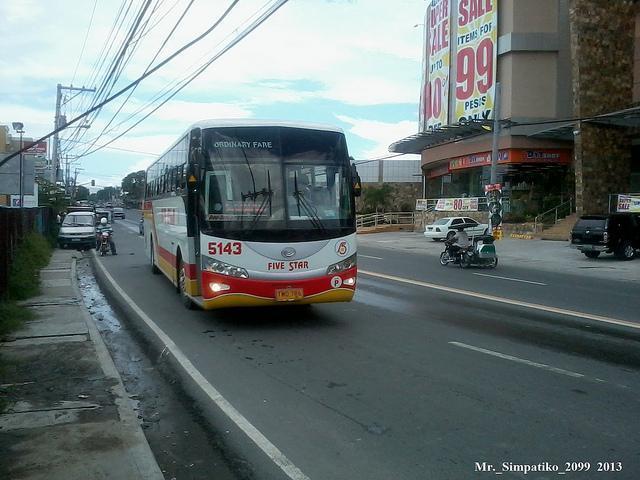What type of sign is on the building?
Select the accurate answer and provide justification: `Answer: choice
Rationale: srationale.`
Options: Informational, directional, warning, brand. Answer: informational.
Rationale: The sign tells about a sale on items. 